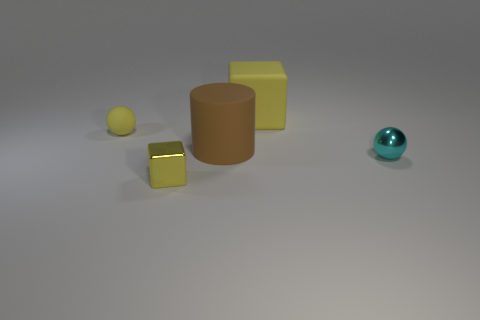There is a small thing that is behind the tiny shiny sphere; is it the same color as the large cube?
Keep it short and to the point. Yes. Is the yellow rubber ball the same size as the brown rubber cylinder?
Offer a terse response. No. There is a tiny rubber object that is the same shape as the tiny cyan metallic object; what is its color?
Make the answer very short. Yellow. How many metal blocks are the same color as the large rubber block?
Give a very brief answer. 1. Are there more big yellow blocks right of the brown matte thing than green rubber things?
Provide a short and direct response. Yes. There is a thing that is right of the yellow thing that is on the right side of the yellow metal block; what color is it?
Your answer should be compact. Cyan. How many things are either matte things that are to the right of the yellow metal cube or matte objects right of the tiny metal block?
Your answer should be very brief. 2. The matte cylinder is what color?
Provide a short and direct response. Brown. What number of large yellow blocks have the same material as the cylinder?
Provide a short and direct response. 1. Is the number of tiny rubber things greater than the number of big purple shiny spheres?
Provide a succinct answer. Yes. 